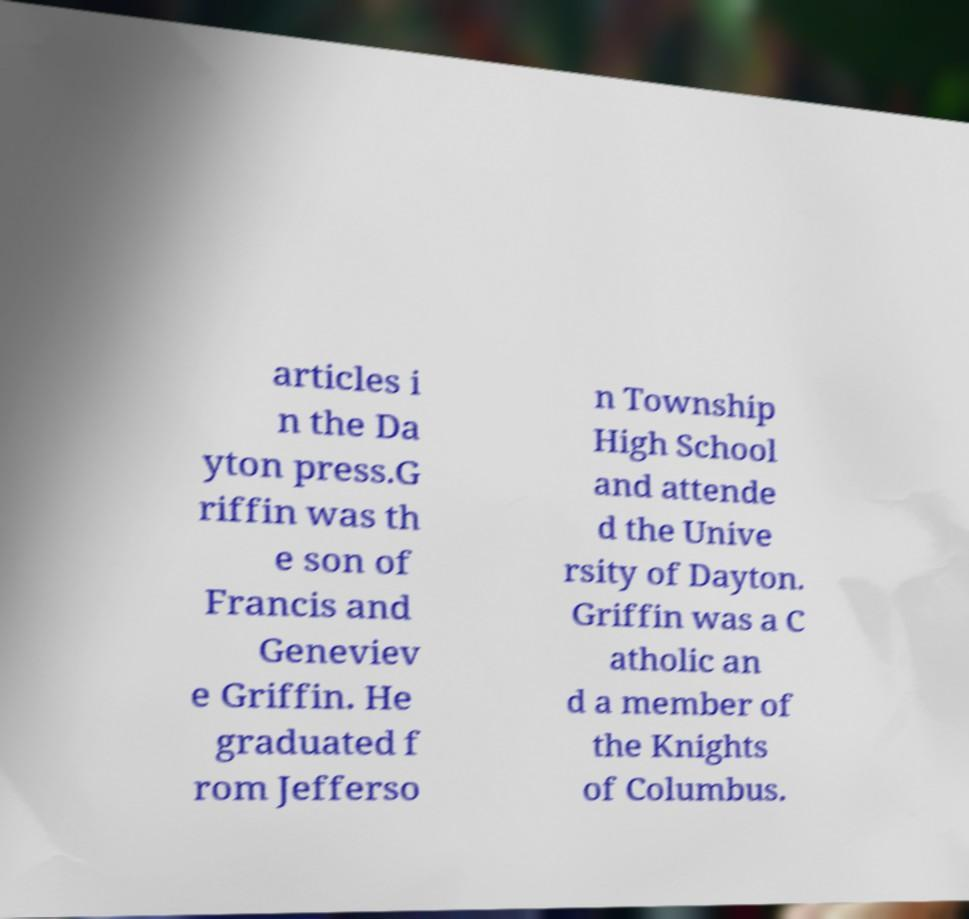What messages or text are displayed in this image? I need them in a readable, typed format. articles i n the Da yton press.G riffin was th e son of Francis and Geneviev e Griffin. He graduated f rom Jefferso n Township High School and attende d the Unive rsity of Dayton. Griffin was a C atholic an d a member of the Knights of Columbus. 